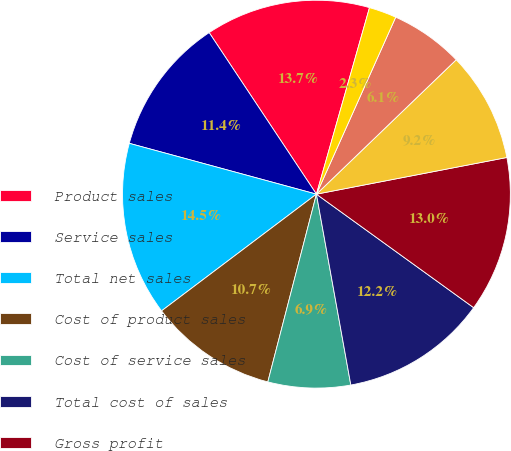Convert chart. <chart><loc_0><loc_0><loc_500><loc_500><pie_chart><fcel>Product sales<fcel>Service sales<fcel>Total net sales<fcel>Cost of product sales<fcel>Cost of service sales<fcel>Total cost of sales<fcel>Gross profit<fcel>Selling and administrative<fcel>Research and development<fcel>Purchased intangibles<nl><fcel>13.74%<fcel>11.45%<fcel>14.5%<fcel>10.69%<fcel>6.87%<fcel>12.21%<fcel>12.98%<fcel>9.16%<fcel>6.11%<fcel>2.29%<nl></chart> 